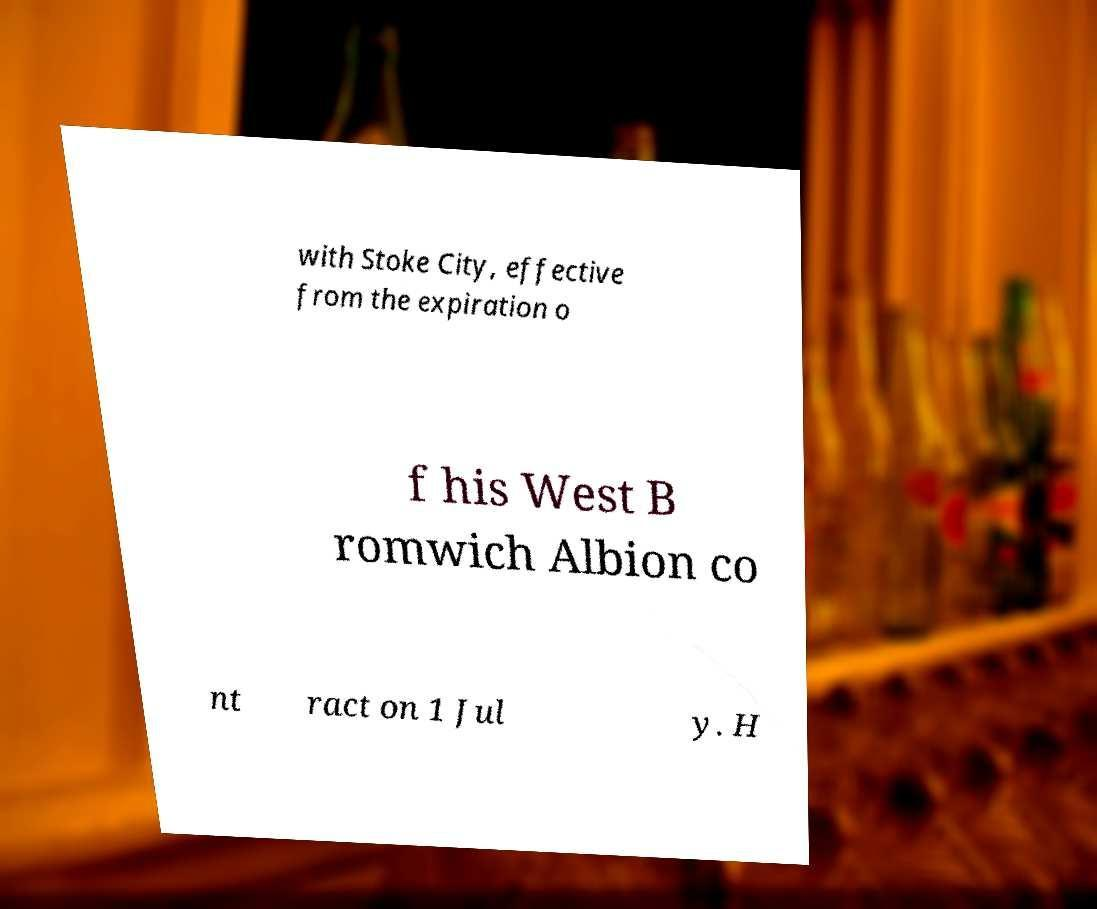I need the written content from this picture converted into text. Can you do that? with Stoke City, effective from the expiration o f his West B romwich Albion co nt ract on 1 Jul y. H 